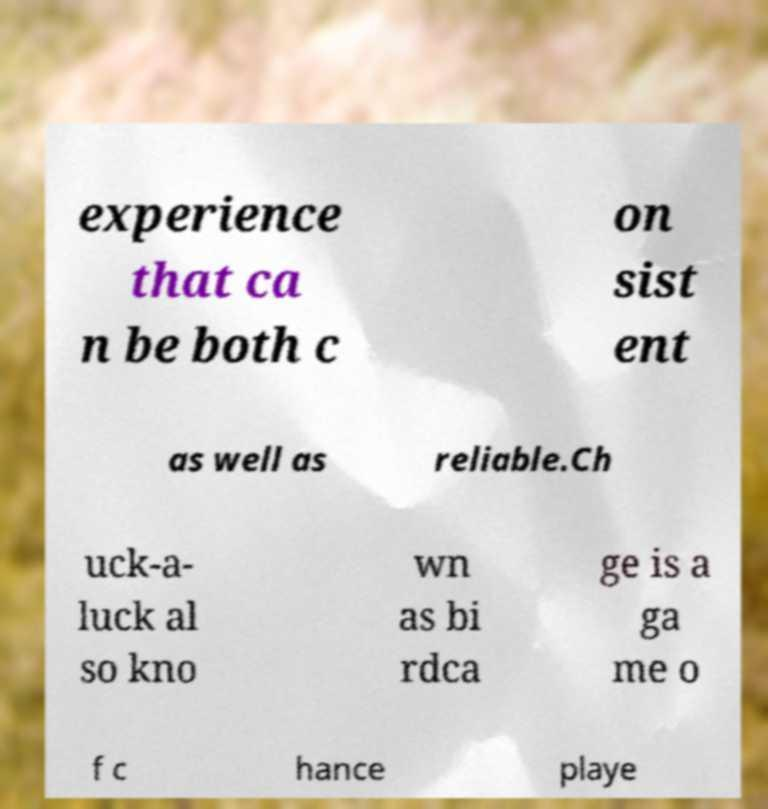There's text embedded in this image that I need extracted. Can you transcribe it verbatim? experience that ca n be both c on sist ent as well as reliable.Ch uck-a- luck al so kno wn as bi rdca ge is a ga me o f c hance playe 